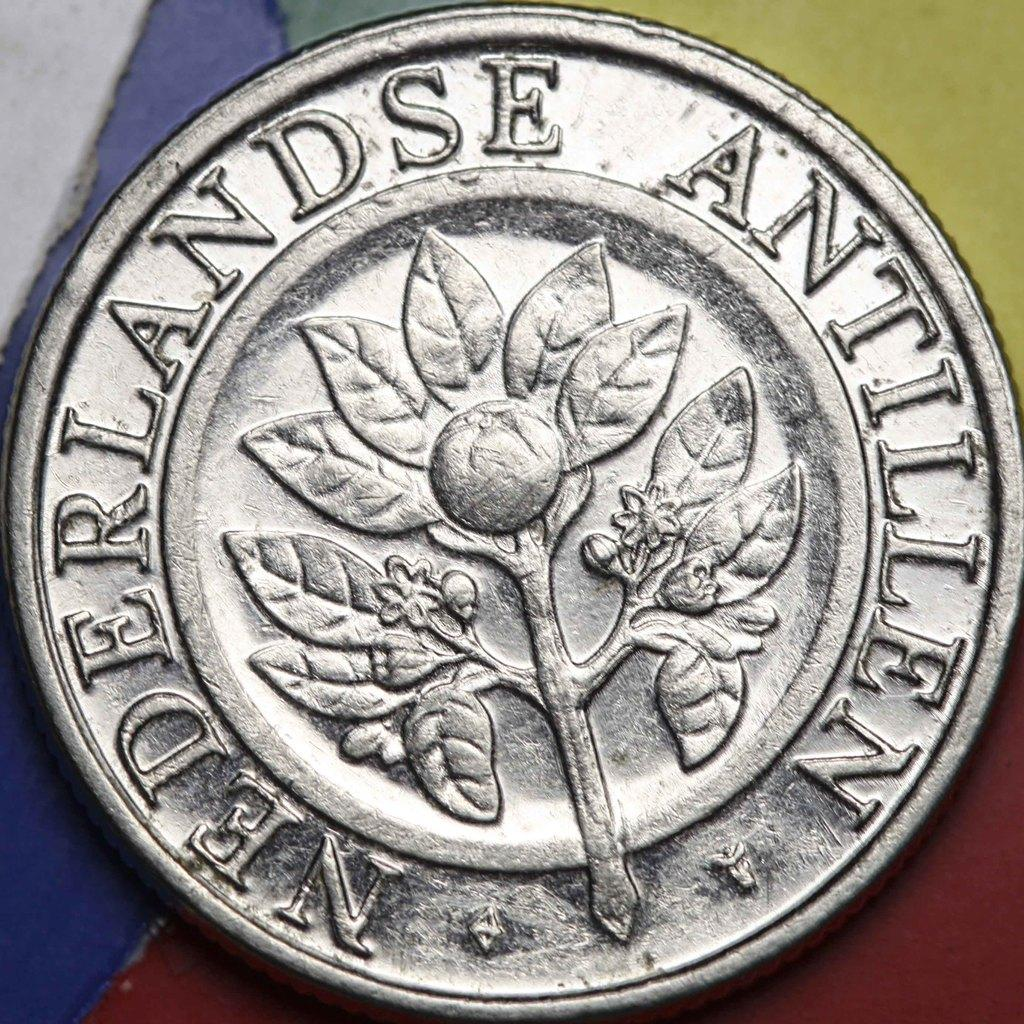What object is in the image? There is a coin in the image. Where is the coin placed? The coin is placed on a table. How is the coin positioned in relation to the image? The coin is located in the center of the image. What type of skin can be seen on the coin in the image? Coins do not have skin; they are made of metal. How much liquid is present on the coin in the image? There is no liquid present on the coin in the image. 